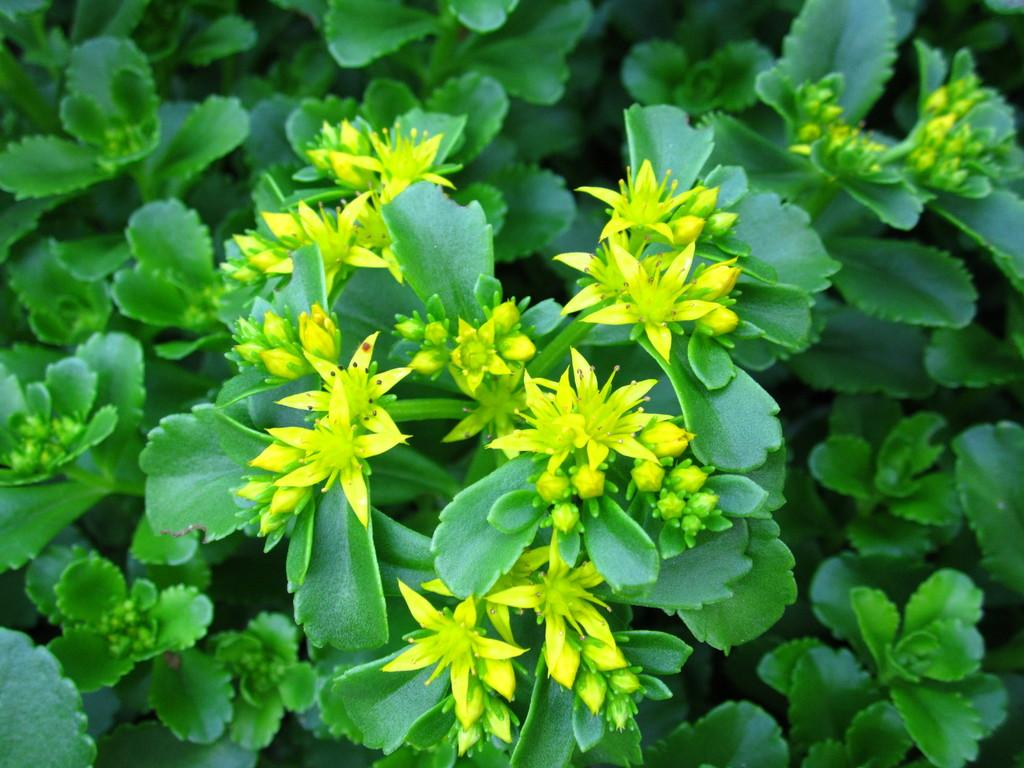What type of plants can be seen in the image? There are flowers in the image. Can you describe the stage of growth of the plants in the image? There are buds on the plants in the image. What type of railway is visible in the image? There is no railway present in the image; it features flowers and buds on plants. How many trucks can be seen in the image? There are no trucks present in the image. 